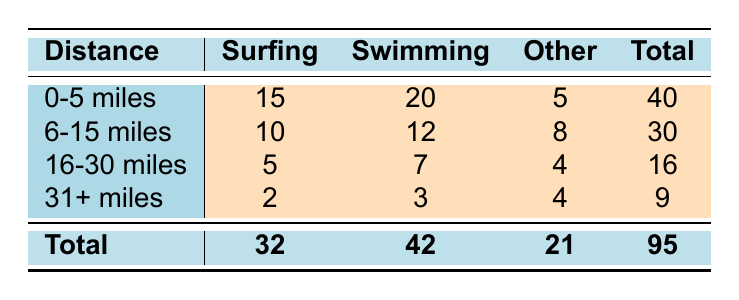What is the total frequency of visits for surfing within 0-5 miles? Referring to the table, the frequency of visits for surfing at a distance of 0-5 miles is 15.
Answer: 15 What is the total frequency of visits for all watersports at a distance of 6-15 miles? To find the total, add the frequencies for each watersport in this distance category: 10 (Surfing) + 12 (Swimming) + 8 (Other) = 30.
Answer: 30 Is swimming the most popular watersport for distances of 16-30 miles? The frequency of visits for swimming in this distance category is 7, while surfing has 5 and fishing has 4. Therefore, swimming is the most popular.
Answer: Yes What is the difference in total frequency of visits between surfing and swimming for all distances combined? For surfing, the total frequency is 32 (0-5 miles) + 10 (6-15 miles) + 5 (16-30 miles) + 2 (31+ miles) = 49. For swimming, the total frequency is 42. The difference is 49 - 42 = 7.
Answer: 7 Which distance category has the highest total frequency of visits? The total frequencies for all categories are: 40 (0-5 miles), 30 (6-15 miles), 16 (16-30 miles), and 9 (31+ miles). The highest total is 40 in the 0-5 miles category.
Answer: 0-5 miles What is the average frequency of visits for watersports in the 31+ miles category? For 31+ miles, the frequencies are 2 (Surfing), 3 (Swimming), and 2 (Other). The average is (2 + 3 + 2) / 3 = 2.33.
Answer: 2.33 Is kayaking part of the "Other" category for the distance of 0-5 miles? Yes, kayaking is included in the Other category with a frequency of 5.
Answer: Yes What is the least popular watersport for a distance of 31+ miles? The frequencies of watersports are: 2 (Surfing), 3 (Swimming), and 2 (Windsurfing). Both surfing and windsurfing have the same lowest frequency of 2.
Answer: Surfing and Windsurfing What is the total frequency of visits for all watersports across all distance categories? By summing the total row of the table: 32 (Surfing) + 42 (Swimming) + 21 (Other) = 95.
Answer: 95 